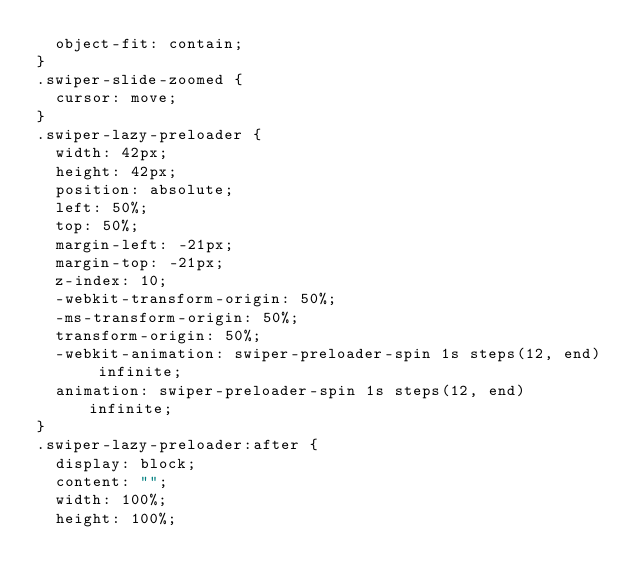<code> <loc_0><loc_0><loc_500><loc_500><_CSS_>  object-fit: contain;
}
.swiper-slide-zoomed {
  cursor: move;
}
.swiper-lazy-preloader {
  width: 42px;
  height: 42px;
  position: absolute;
  left: 50%;
  top: 50%;
  margin-left: -21px;
  margin-top: -21px;
  z-index: 10;
  -webkit-transform-origin: 50%;
  -ms-transform-origin: 50%;
  transform-origin: 50%;
  -webkit-animation: swiper-preloader-spin 1s steps(12, end) infinite;
  animation: swiper-preloader-spin 1s steps(12, end) infinite;
}
.swiper-lazy-preloader:after {
  display: block;
  content: "";
  width: 100%;
  height: 100%;</code> 